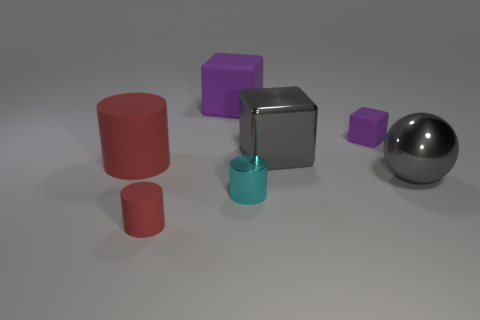Subtract all blue cylinders. Subtract all brown cubes. How many cylinders are left? 3 Add 3 tiny things. How many objects exist? 10 Subtract all cylinders. How many objects are left? 4 Subtract 0 yellow balls. How many objects are left? 7 Subtract all cyan metal cylinders. Subtract all brown blocks. How many objects are left? 6 Add 3 large gray metallic blocks. How many large gray metallic blocks are left? 4 Add 2 tiny rubber objects. How many tiny rubber objects exist? 4 